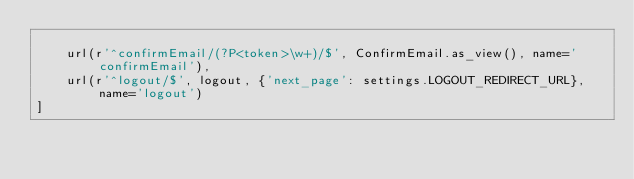<code> <loc_0><loc_0><loc_500><loc_500><_Python_>
    url(r'^confirmEmail/(?P<token>\w+)/$', ConfirmEmail.as_view(), name='confirmEmail'),
    url(r'^logout/$', logout, {'next_page': settings.LOGOUT_REDIRECT_URL}, name='logout')
]</code> 